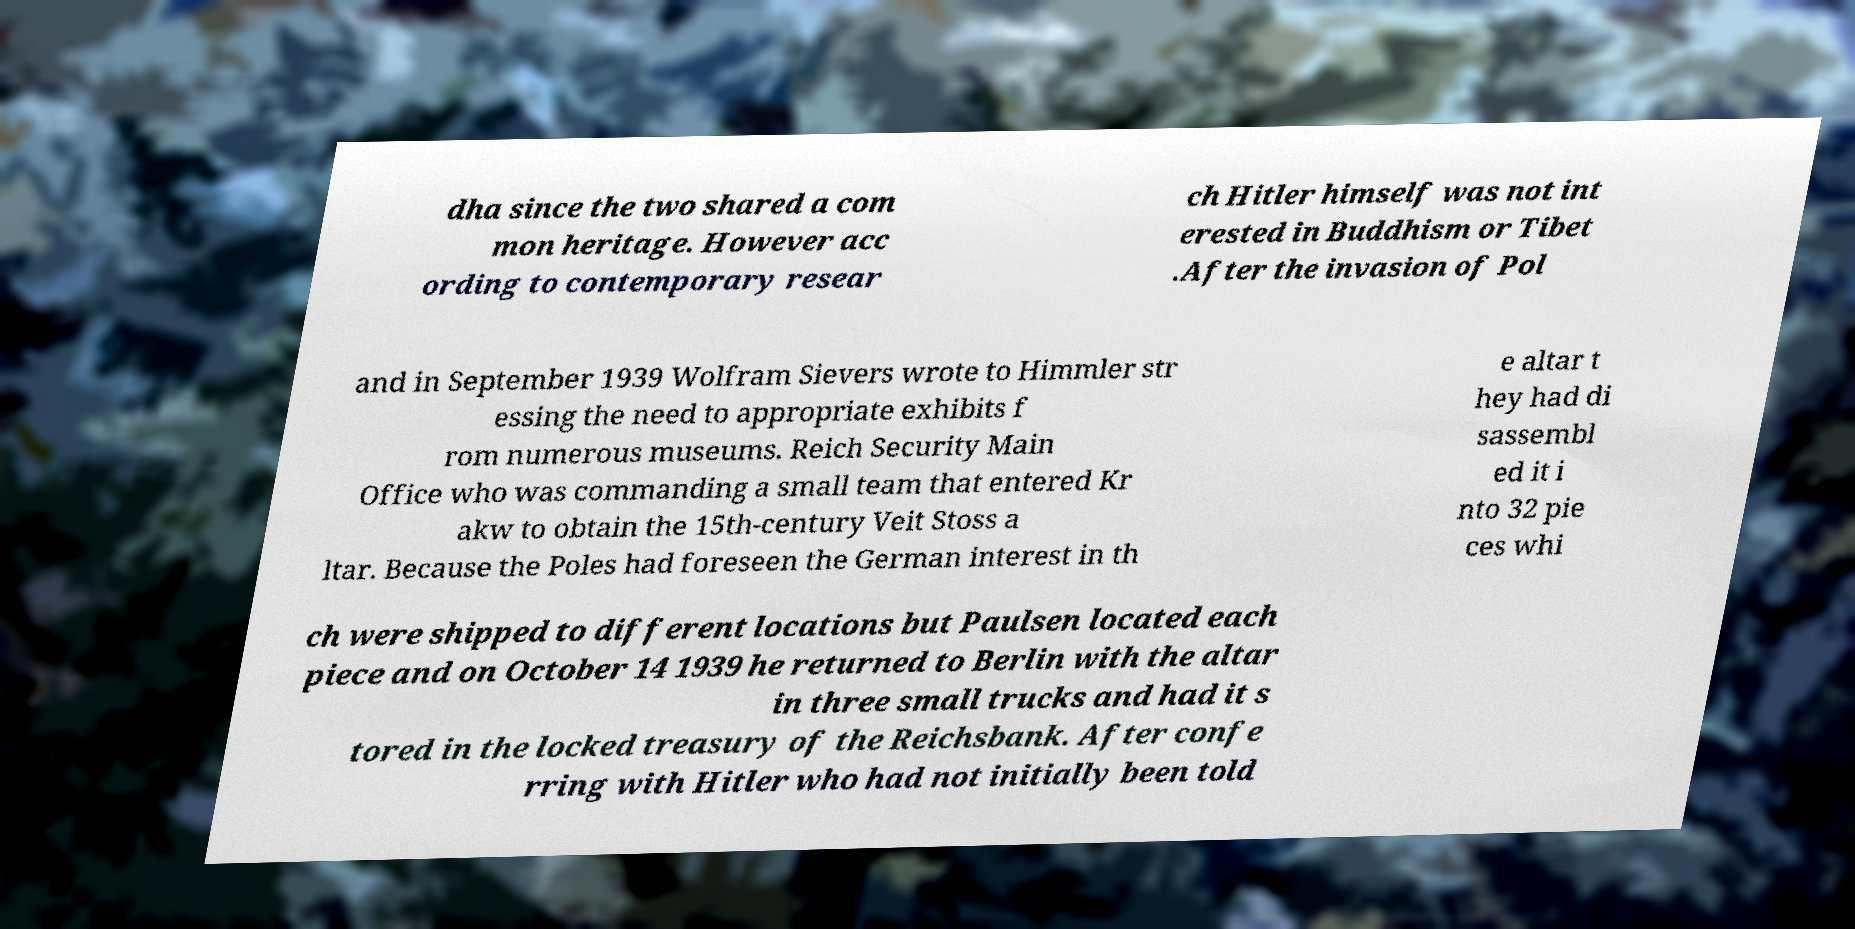I need the written content from this picture converted into text. Can you do that? dha since the two shared a com mon heritage. However acc ording to contemporary resear ch Hitler himself was not int erested in Buddhism or Tibet .After the invasion of Pol and in September 1939 Wolfram Sievers wrote to Himmler str essing the need to appropriate exhibits f rom numerous museums. Reich Security Main Office who was commanding a small team that entered Kr akw to obtain the 15th-century Veit Stoss a ltar. Because the Poles had foreseen the German interest in th e altar t hey had di sassembl ed it i nto 32 pie ces whi ch were shipped to different locations but Paulsen located each piece and on October 14 1939 he returned to Berlin with the altar in three small trucks and had it s tored in the locked treasury of the Reichsbank. After confe rring with Hitler who had not initially been told 